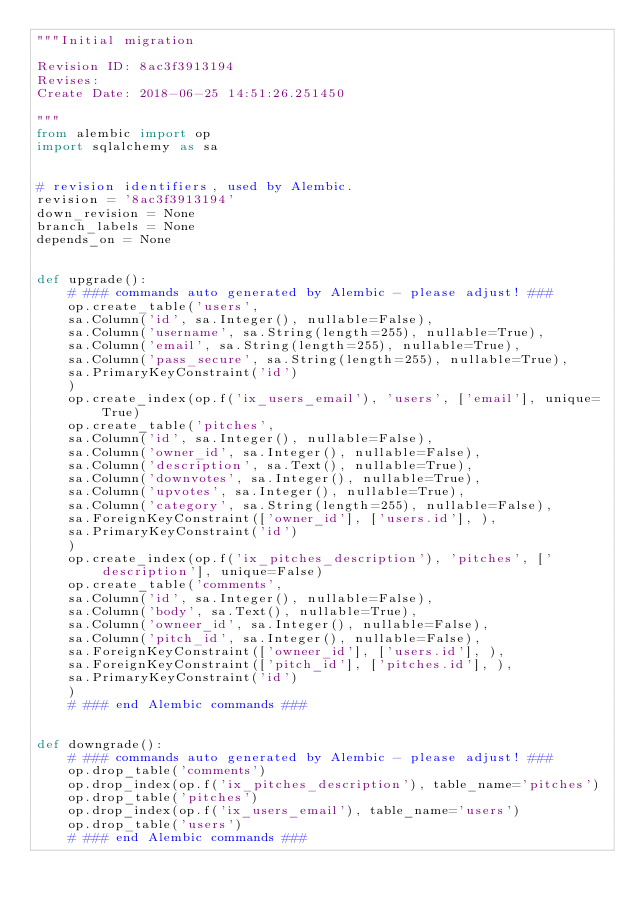<code> <loc_0><loc_0><loc_500><loc_500><_Python_>"""Initial migration

Revision ID: 8ac3f3913194
Revises: 
Create Date: 2018-06-25 14:51:26.251450

"""
from alembic import op
import sqlalchemy as sa


# revision identifiers, used by Alembic.
revision = '8ac3f3913194'
down_revision = None
branch_labels = None
depends_on = None


def upgrade():
    # ### commands auto generated by Alembic - please adjust! ###
    op.create_table('users',
    sa.Column('id', sa.Integer(), nullable=False),
    sa.Column('username', sa.String(length=255), nullable=True),
    sa.Column('email', sa.String(length=255), nullable=True),
    sa.Column('pass_secure', sa.String(length=255), nullable=True),
    sa.PrimaryKeyConstraint('id')
    )
    op.create_index(op.f('ix_users_email'), 'users', ['email'], unique=True)
    op.create_table('pitches',
    sa.Column('id', sa.Integer(), nullable=False),
    sa.Column('owner_id', sa.Integer(), nullable=False),
    sa.Column('description', sa.Text(), nullable=True),
    sa.Column('downvotes', sa.Integer(), nullable=True),
    sa.Column('upvotes', sa.Integer(), nullable=True),
    sa.Column('category', sa.String(length=255), nullable=False),
    sa.ForeignKeyConstraint(['owner_id'], ['users.id'], ),
    sa.PrimaryKeyConstraint('id')
    )
    op.create_index(op.f('ix_pitches_description'), 'pitches', ['description'], unique=False)
    op.create_table('comments',
    sa.Column('id', sa.Integer(), nullable=False),
    sa.Column('body', sa.Text(), nullable=True),
    sa.Column('owneer_id', sa.Integer(), nullable=False),
    sa.Column('pitch_id', sa.Integer(), nullable=False),
    sa.ForeignKeyConstraint(['owneer_id'], ['users.id'], ),
    sa.ForeignKeyConstraint(['pitch_id'], ['pitches.id'], ),
    sa.PrimaryKeyConstraint('id')
    )
    # ### end Alembic commands ###


def downgrade():
    # ### commands auto generated by Alembic - please adjust! ###
    op.drop_table('comments')
    op.drop_index(op.f('ix_pitches_description'), table_name='pitches')
    op.drop_table('pitches')
    op.drop_index(op.f('ix_users_email'), table_name='users')
    op.drop_table('users')
    # ### end Alembic commands ###
</code> 